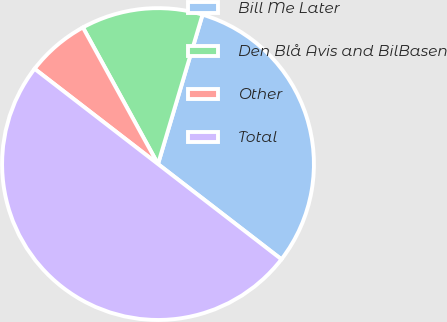<chart> <loc_0><loc_0><loc_500><loc_500><pie_chart><fcel>Bill Me Later<fcel>Den Blå Avis and BilBasen<fcel>Other<fcel>Total<nl><fcel>30.85%<fcel>12.61%<fcel>6.54%<fcel>50.0%<nl></chart> 